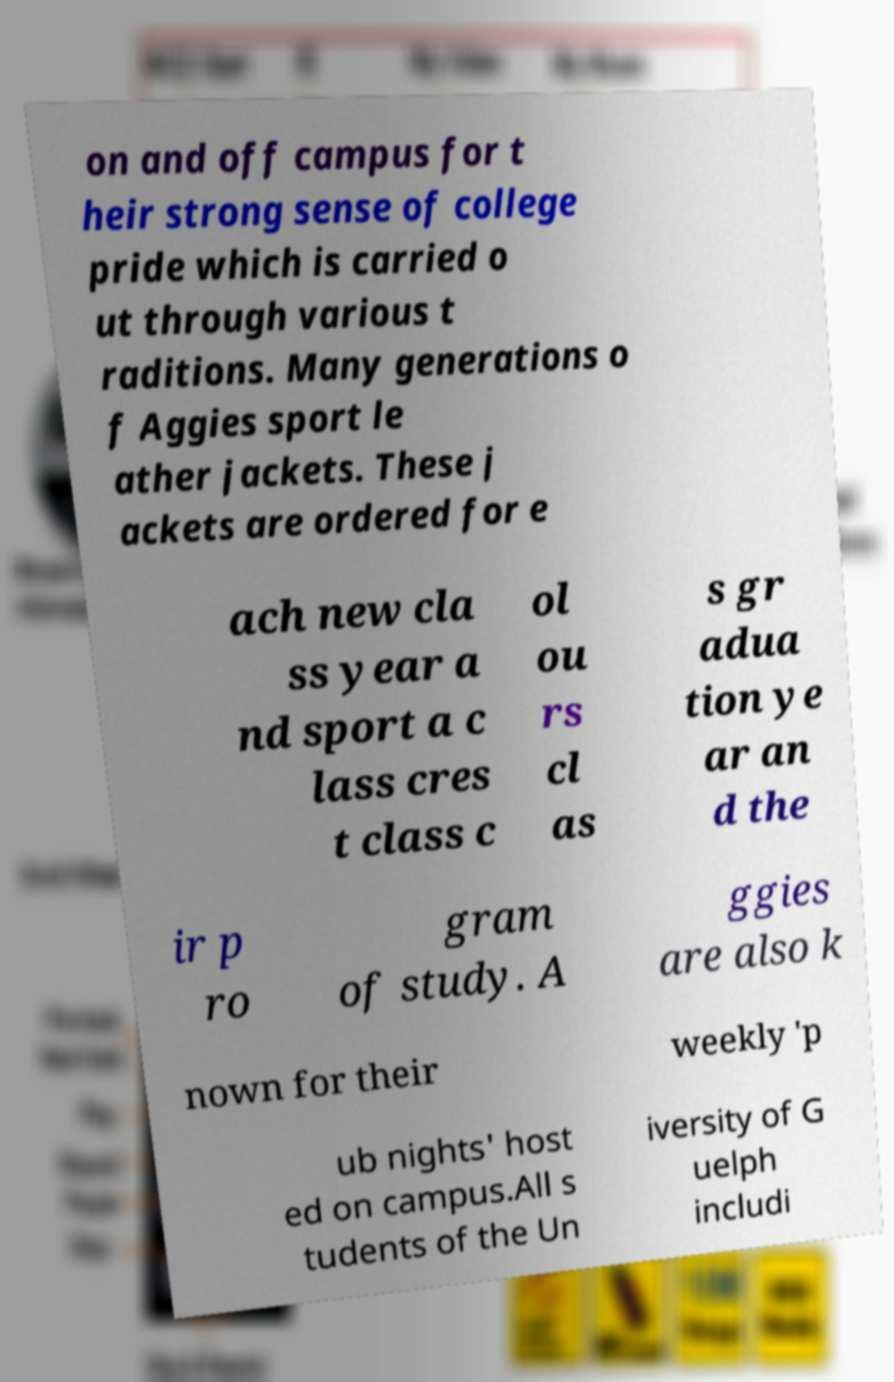Can you read and provide the text displayed in the image?This photo seems to have some interesting text. Can you extract and type it out for me? on and off campus for t heir strong sense of college pride which is carried o ut through various t raditions. Many generations o f Aggies sport le ather jackets. These j ackets are ordered for e ach new cla ss year a nd sport a c lass cres t class c ol ou rs cl as s gr adua tion ye ar an d the ir p ro gram of study. A ggies are also k nown for their weekly 'p ub nights' host ed on campus.All s tudents of the Un iversity of G uelph includi 